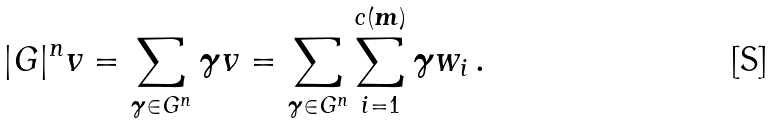Convert formula to latex. <formula><loc_0><loc_0><loc_500><loc_500>| G | ^ { n } v = \sum _ { \boldsymbol \gamma \in G ^ { n } } \boldsymbol \gamma v = \sum _ { \boldsymbol \gamma \in G ^ { n } } \sum _ { i = 1 } ^ { c ( \boldsymbol m ) } \boldsymbol \gamma w _ { i } \, .</formula> 